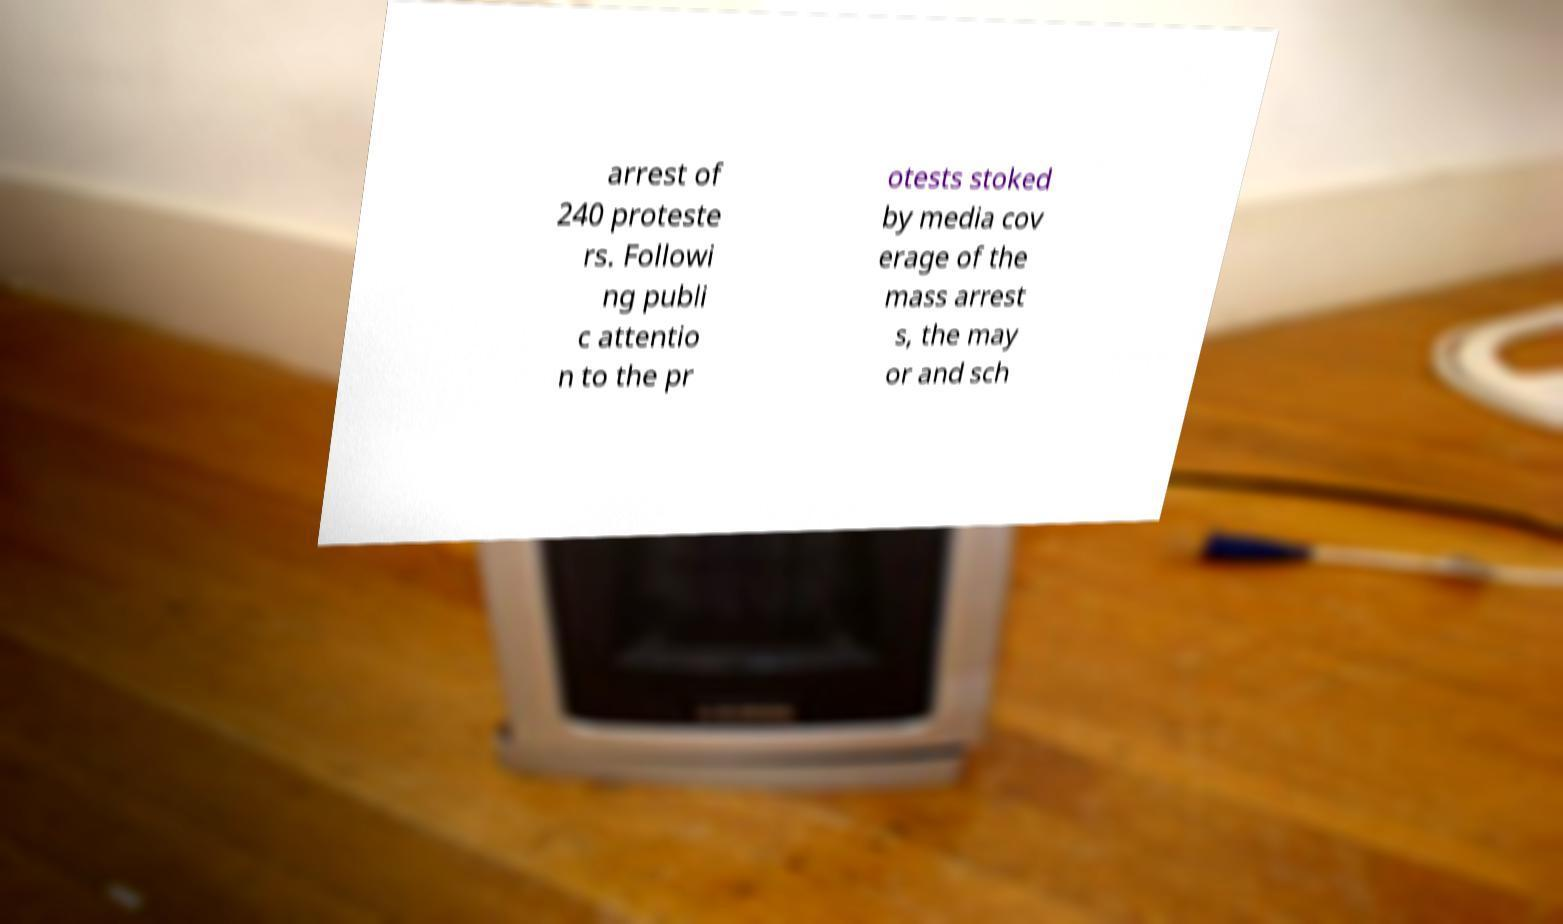For documentation purposes, I need the text within this image transcribed. Could you provide that? arrest of 240 proteste rs. Followi ng publi c attentio n to the pr otests stoked by media cov erage of the mass arrest s, the may or and sch 